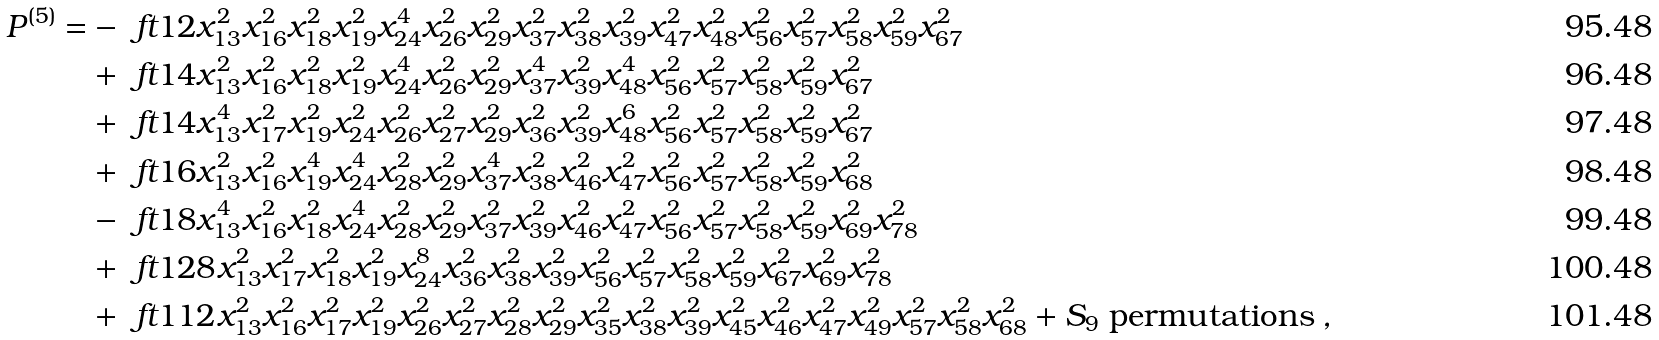Convert formula to latex. <formula><loc_0><loc_0><loc_500><loc_500>P ^ { \text {(5)} } = & - \ f t { 1 } { 2 } x _ { 1 3 } ^ { 2 } x _ { 1 6 } ^ { 2 } x _ { 1 8 } ^ { 2 } x _ { 1 9 } ^ { 2 } x _ { 2 4 } ^ { 4 } x _ { 2 6 } ^ { 2 } x _ { 2 9 } ^ { 2 } x _ { 3 7 } ^ { 2 } x _ { 3 8 } ^ { 2 } x _ { 3 9 } ^ { 2 } x _ { 4 7 } ^ { 2 } x _ { 4 8 } ^ { 2 } x _ { 5 6 } ^ { 2 } x _ { 5 7 } ^ { 2 } x _ { 5 8 } ^ { 2 } x _ { 5 9 } ^ { 2 } x _ { 6 7 } ^ { 2 } \\ & + \ f t { 1 } { 4 } x _ { 1 3 } ^ { 2 } x _ { 1 6 } ^ { 2 } x _ { 1 8 } ^ { 2 } x _ { 1 9 } ^ { 2 } x _ { 2 4 } ^ { 4 } x _ { 2 6 } ^ { 2 } x _ { 2 9 } ^ { 2 } x _ { 3 7 } ^ { 4 } x _ { 3 9 } ^ { 2 } x _ { 4 8 } ^ { 4 } x _ { 5 6 } ^ { 2 } x _ { 5 7 } ^ { 2 } x _ { 5 8 } ^ { 2 } x _ { 5 9 } ^ { 2 } x _ { 6 7 } ^ { 2 } \\ & + \ f t { 1 } { 4 } x _ { 1 3 } ^ { 4 } x _ { 1 7 } ^ { 2 } x _ { 1 9 } ^ { 2 } x _ { 2 4 } ^ { 2 } x _ { 2 6 } ^ { 2 } x _ { 2 7 } ^ { 2 } x _ { 2 9 } ^ { 2 } x _ { 3 6 } ^ { 2 } x _ { 3 9 } ^ { 2 } x _ { 4 8 } ^ { 6 } x _ { 5 6 } ^ { 2 } x _ { 5 7 } ^ { 2 } x _ { 5 8 } ^ { 2 } x _ { 5 9 } ^ { 2 } x _ { 6 7 } ^ { 2 } \\ & + \ f t { 1 } { 6 } x _ { 1 3 } ^ { 2 } x _ { 1 6 } ^ { 2 } x _ { 1 9 } ^ { 4 } x _ { 2 4 } ^ { 4 } x _ { 2 8 } ^ { 2 } x _ { 2 9 } ^ { 2 } x _ { 3 7 } ^ { 4 } x _ { 3 8 } ^ { 2 } x _ { 4 6 } ^ { 2 } x _ { 4 7 } ^ { 2 } x _ { 5 6 } ^ { 2 } x _ { 5 7 } ^ { 2 } x _ { 5 8 } ^ { 2 } x _ { 5 9 } ^ { 2 } x _ { 6 8 } ^ { 2 } \\ & - \ f t { 1 } { 8 } x _ { 1 3 } ^ { 4 } x _ { 1 6 } ^ { 2 } x _ { 1 8 } ^ { 2 } x _ { 2 4 } ^ { 4 } x _ { 2 8 } ^ { 2 } x _ { 2 9 } ^ { 2 } x _ { 3 7 } ^ { 2 } x _ { 3 9 } ^ { 2 } x _ { 4 6 } ^ { 2 } x _ { 4 7 } ^ { 2 } x _ { 5 6 } ^ { 2 } x _ { 5 7 } ^ { 2 } x _ { 5 8 } ^ { 2 } x _ { 5 9 } ^ { 2 } x _ { 6 9 } ^ { 2 } x _ { 7 8 } ^ { 2 } \\ & + \ f t { 1 } { 2 8 } x _ { 1 3 } ^ { 2 } x _ { 1 7 } ^ { 2 } x _ { 1 8 } ^ { 2 } x _ { 1 9 } ^ { 2 } x _ { 2 4 } ^ { 8 } x _ { 3 6 } ^ { 2 } x _ { 3 8 } ^ { 2 } x _ { 3 9 } ^ { 2 } x _ { 5 6 } ^ { 2 } x _ { 5 7 } ^ { 2 } x _ { 5 8 } ^ { 2 } x _ { 5 9 } ^ { 2 } x _ { 6 7 } ^ { 2 } x _ { 6 9 } ^ { 2 } x _ { 7 8 } ^ { 2 } \\ & + \ f t { 1 } { 1 2 } x _ { 1 3 } ^ { 2 } x _ { 1 6 } ^ { 2 } x _ { 1 7 } ^ { 2 } x _ { 1 9 } ^ { 2 } x _ { 2 6 } ^ { 2 } x _ { 2 7 } ^ { 2 } x _ { 2 8 } ^ { 2 } x _ { 2 9 } ^ { 2 } x _ { 3 5 } ^ { 2 } x _ { 3 8 } ^ { 2 } x _ { 3 9 } ^ { 2 } x _ { 4 5 } ^ { 2 } x _ { 4 6 } ^ { 2 } x _ { 4 7 } ^ { 2 } x _ { 4 9 } ^ { 2 } x _ { 5 7 } ^ { 2 } x _ { 5 8 } ^ { 2 } x _ { 6 8 } ^ { 2 } + \text {$S_{9}$ permutations} \, ,</formula> 